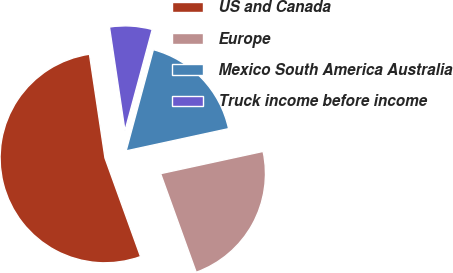<chart> <loc_0><loc_0><loc_500><loc_500><pie_chart><fcel>US and Canada<fcel>Europe<fcel>Mexico South America Australia<fcel>Truck income before income<nl><fcel>53.14%<fcel>22.89%<fcel>17.41%<fcel>6.55%<nl></chart> 